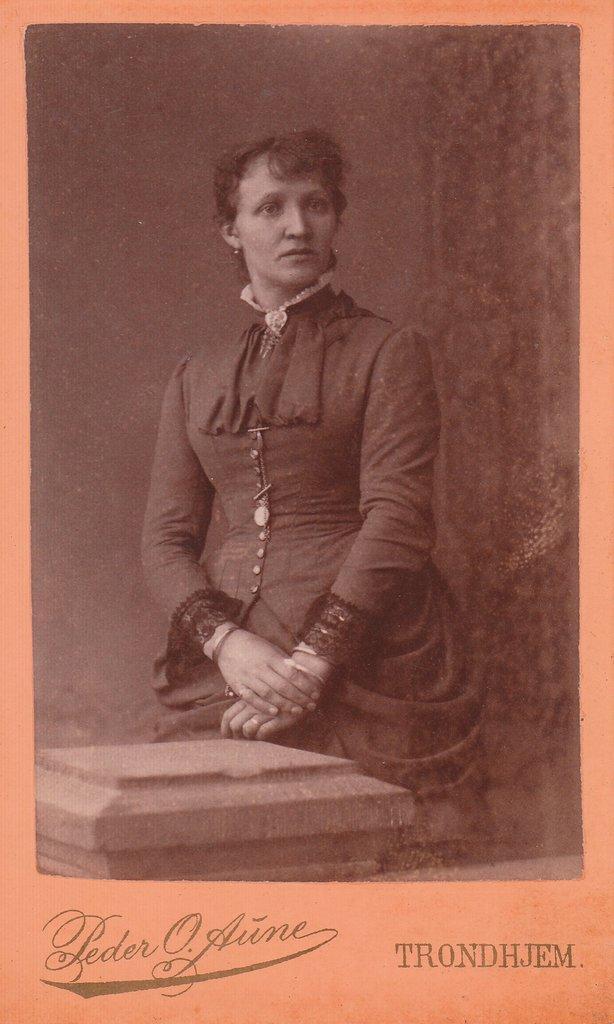Describe this image in one or two sentences. In the foreground of this poster there is a lady standing. There is text at the bottom. It looks like a wall in the background. 